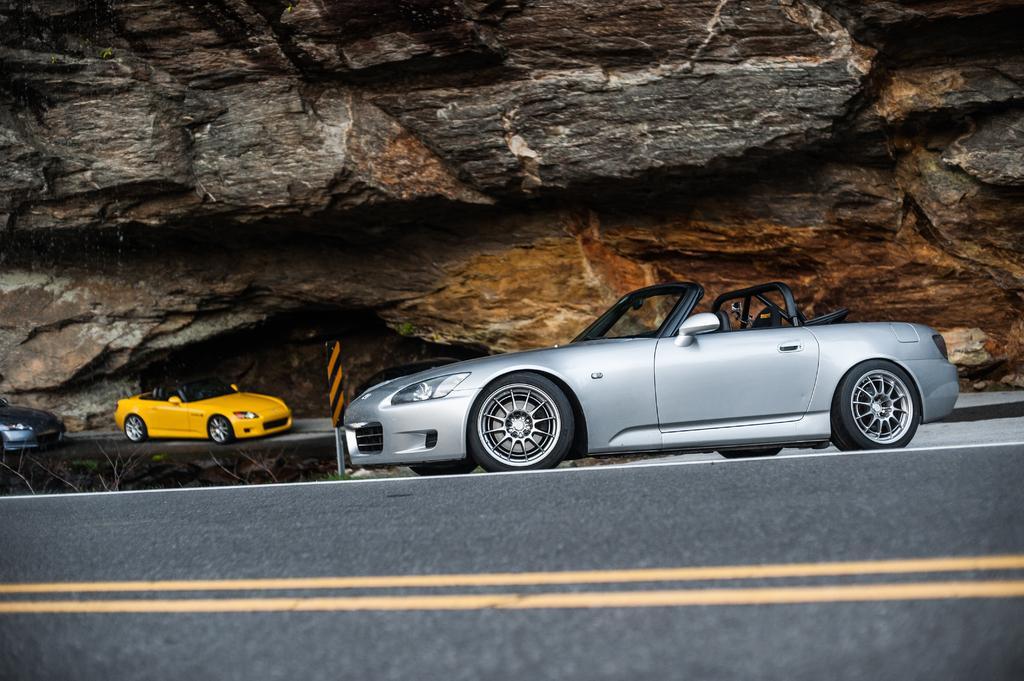In one or two sentences, can you explain what this image depicts? In this image there are cars on the road ,under the rock. 